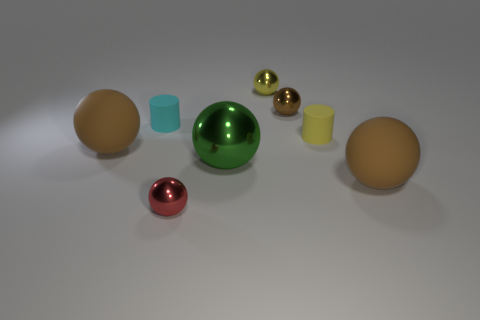What material is the brown ball in front of the brown rubber ball that is left of the rubber cylinder on the left side of the red object made of?
Offer a very short reply. Rubber. How many other objects are the same size as the cyan rubber cylinder?
Offer a terse response. 4. What material is the small yellow object that is the same shape as the cyan thing?
Keep it short and to the point. Rubber. What color is the big shiny ball?
Keep it short and to the point. Green. There is a big rubber sphere to the right of the brown matte object left of the yellow ball; what is its color?
Offer a terse response. Brown. There is a brown sphere in front of the matte ball that is to the left of the yellow metallic sphere; what number of big matte things are on the left side of it?
Offer a terse response. 1. Are there any big brown rubber spheres left of the yellow rubber cylinder?
Keep it short and to the point. Yes. What number of spheres are small red things or large things?
Offer a very short reply. 4. How many things are both on the left side of the small yellow metallic sphere and on the right side of the cyan thing?
Make the answer very short. 2. Are there an equal number of small yellow objects that are to the left of the small yellow ball and red things behind the tiny brown shiny thing?
Offer a very short reply. Yes. 